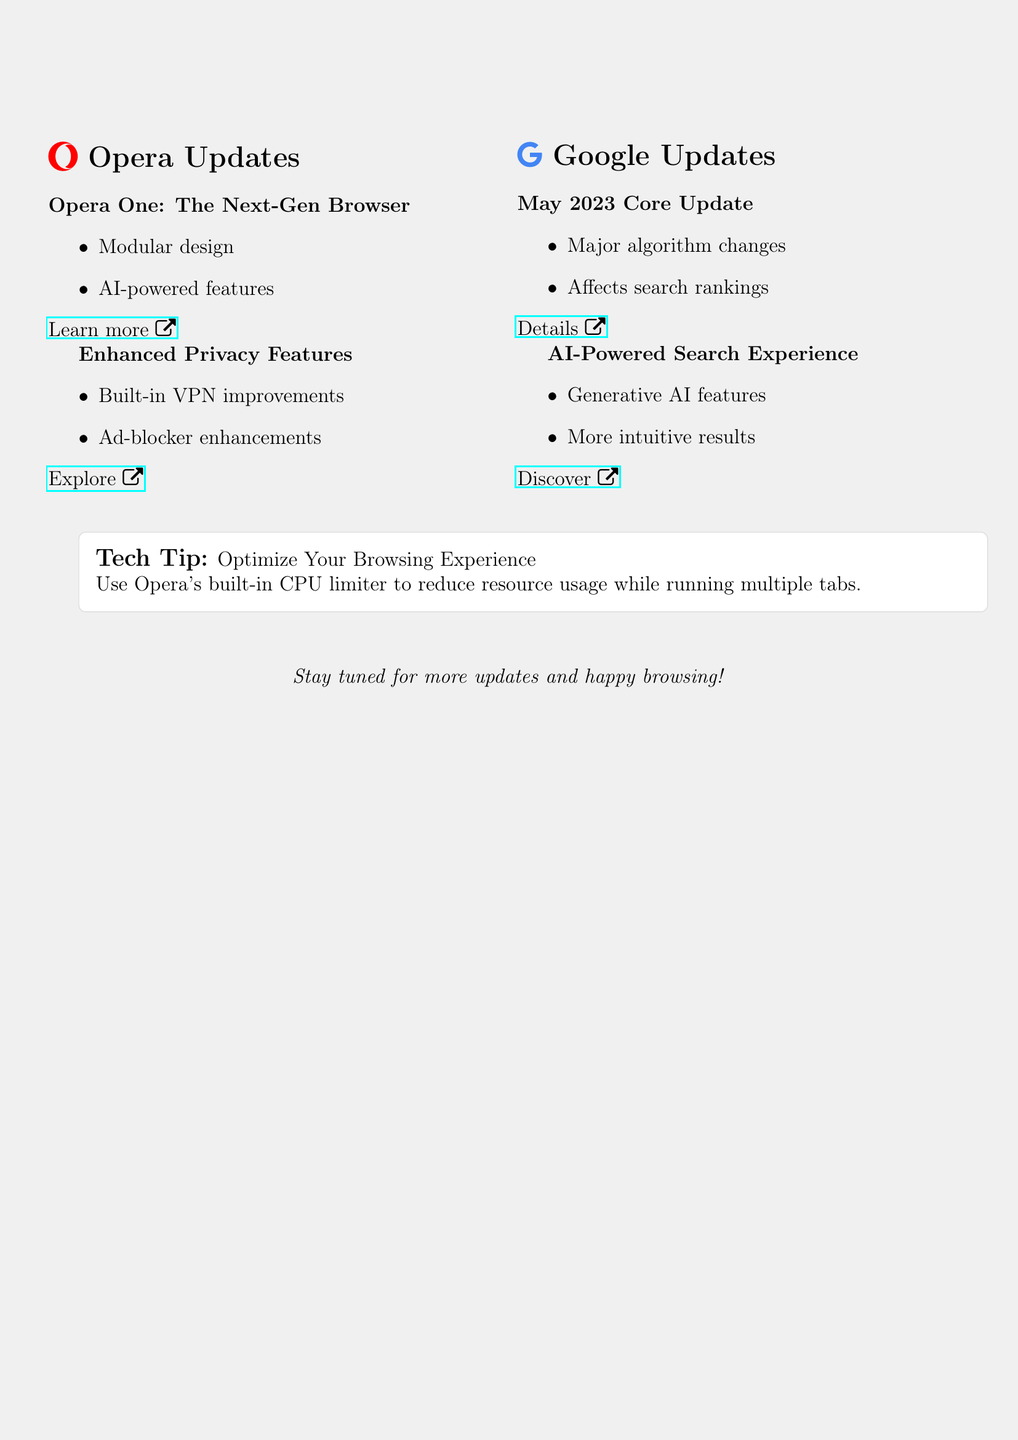What is the subject of the newsletter? The subject is stated at the beginning of the document to indicate the main topic being discussed, which includes updates on Opera and Google.
Answer: Opera & Google Updates: What's New for Tech Enthusiasts What are the new features of Opera One? The document lists the major features introduced in Opera One, specifically regarding its design and capabilities.
Answer: Modular design and AI-powered features What are the two enhancements mentioned for Opera's privacy features? The newsletter details improvements in two specific areas of Opera's privacy tools, which are crucial for user security.
Answer: Built-in VPN and ad-blocker improvements When was Google's May 2023 Core Update released? The document references the specific update and its timing as significant in the context of search rankings.
Answer: May 2023 What is an AI-related feature introduced by Google in their search? The newsletter highlights a significant feature that integrates modern technology into Google search functionality.
Answer: Generative AI features What does the tech tip suggest you do to optimize browsing? The tech tip conveys advice on resource management while using the Opera browser, important for users with multiple tabs open.
Answer: Use Opera's built-in CPU limiter What does the newsletter aim to do for tech enthusiasts? The document concludes with an invitation to stay updated, emphasizing ongoing engagement with the latest tech developments.
Answer: Stay tuned for more updates How is the information in the newsletter structured? The document is organized into sections, each covering updates about different topics related to Opera and Google, making it easy to navigate.
Answer: Two main sections: Opera Updates and Google Updates 